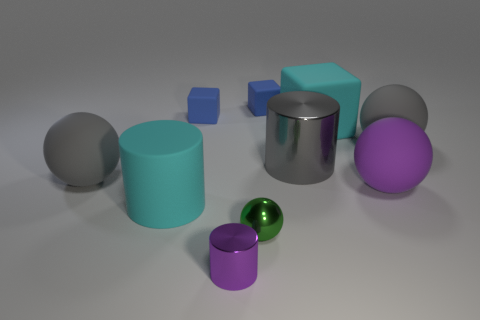There is a thing that is on the right side of the small cylinder and in front of the large purple matte ball; what shape is it?
Provide a short and direct response. Sphere. The matte sphere that is the same color as the tiny cylinder is what size?
Provide a succinct answer. Large. How many objects are large spheres on the right side of the cyan cylinder or green spheres that are on the right side of the cyan cylinder?
Provide a succinct answer. 3. There is a matte cylinder; are there any big purple rubber spheres in front of it?
Provide a succinct answer. No. What color is the big object that is behind the sphere that is behind the big matte sphere that is left of the cyan cube?
Offer a terse response. Cyan. Does the green metal thing have the same shape as the purple metallic thing?
Ensure brevity in your answer.  No. There is a big cylinder that is made of the same material as the tiny sphere; what color is it?
Offer a very short reply. Gray. How many things are either cyan things that are behind the big purple sphere or gray matte things?
Provide a short and direct response. 3. How big is the cyan rubber thing that is on the right side of the big gray metal thing?
Your answer should be compact. Large. There is a cyan cylinder; does it have the same size as the cylinder that is in front of the tiny green ball?
Provide a short and direct response. No. 